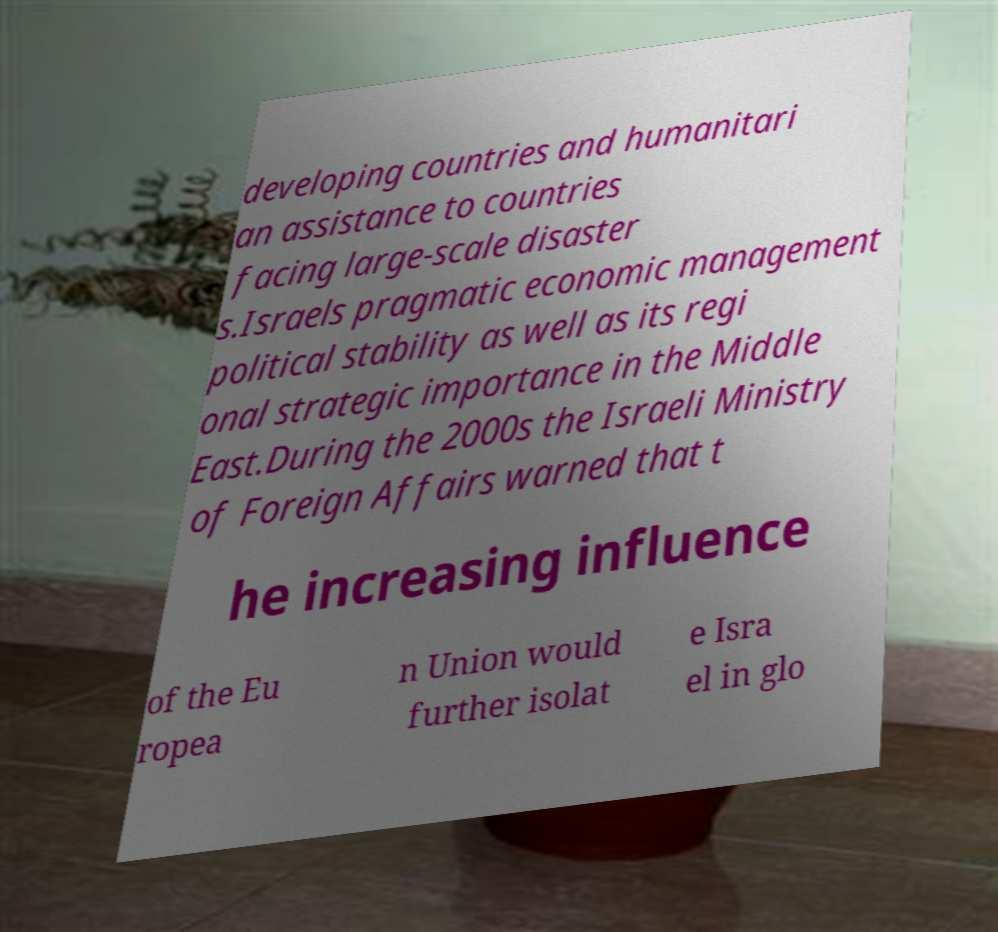Please read and relay the text visible in this image. What does it say? developing countries and humanitari an assistance to countries facing large-scale disaster s.Israels pragmatic economic management political stability as well as its regi onal strategic importance in the Middle East.During the 2000s the Israeli Ministry of Foreign Affairs warned that t he increasing influence of the Eu ropea n Union would further isolat e Isra el in glo 